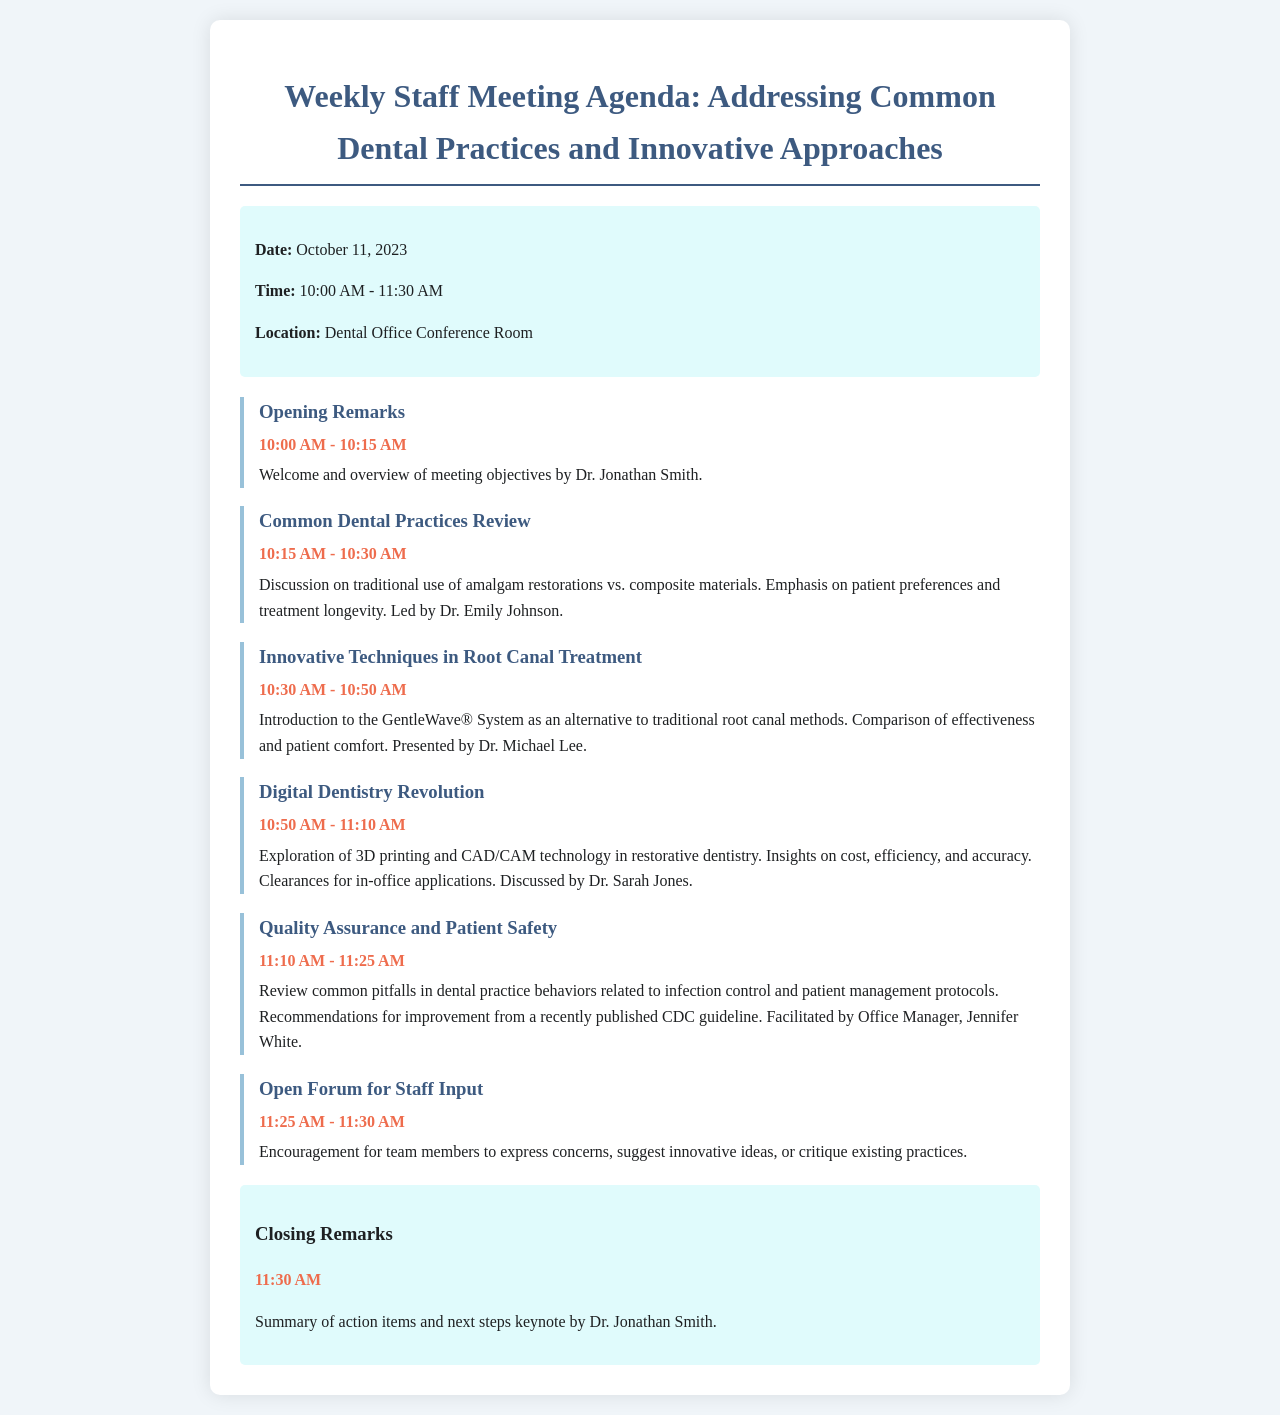What is the date of the meeting? The meeting date is explicitly mentioned in the document under meeting info.
Answer: October 11, 2023 Who is facilitating the Quality Assurance and Patient Safety discussion? The document lists who is leading each agenda item, making it clear who is responsible for the Quality Assurance discussion.
Answer: Jennifer White What innovative technique is introduced for root canal treatment? The document specifically details the innovative technique being discussed in that particular agenda item.
Answer: GentleWave® System What time does the Common Dental Practices Review start? The starting time for each agenda item is indicated clearly in the schedule.
Answer: 10:15 AM How long is the Open Forum for Staff Input? The duration of each agenda item is specified, allowing for a clear calculation of the time for each discussion.
Answer: 5 minutes What technology is explored during the Digital Dentistry Revolution discussion? The document precisely identifies the technology that will be discussed in that section of the agenda.
Answer: 3D printing and CAD/CAM technology What is the main focus of the agenda item led by Dr. Emily Johnson? The agenda item summaries help to determine the main topic being addressed by each presenter.
Answer: Amalgam restorations vs. composite materials What is the closing time of the meeting? The closing time is given in the closing remarks section of the document.
Answer: 11:30 AM 